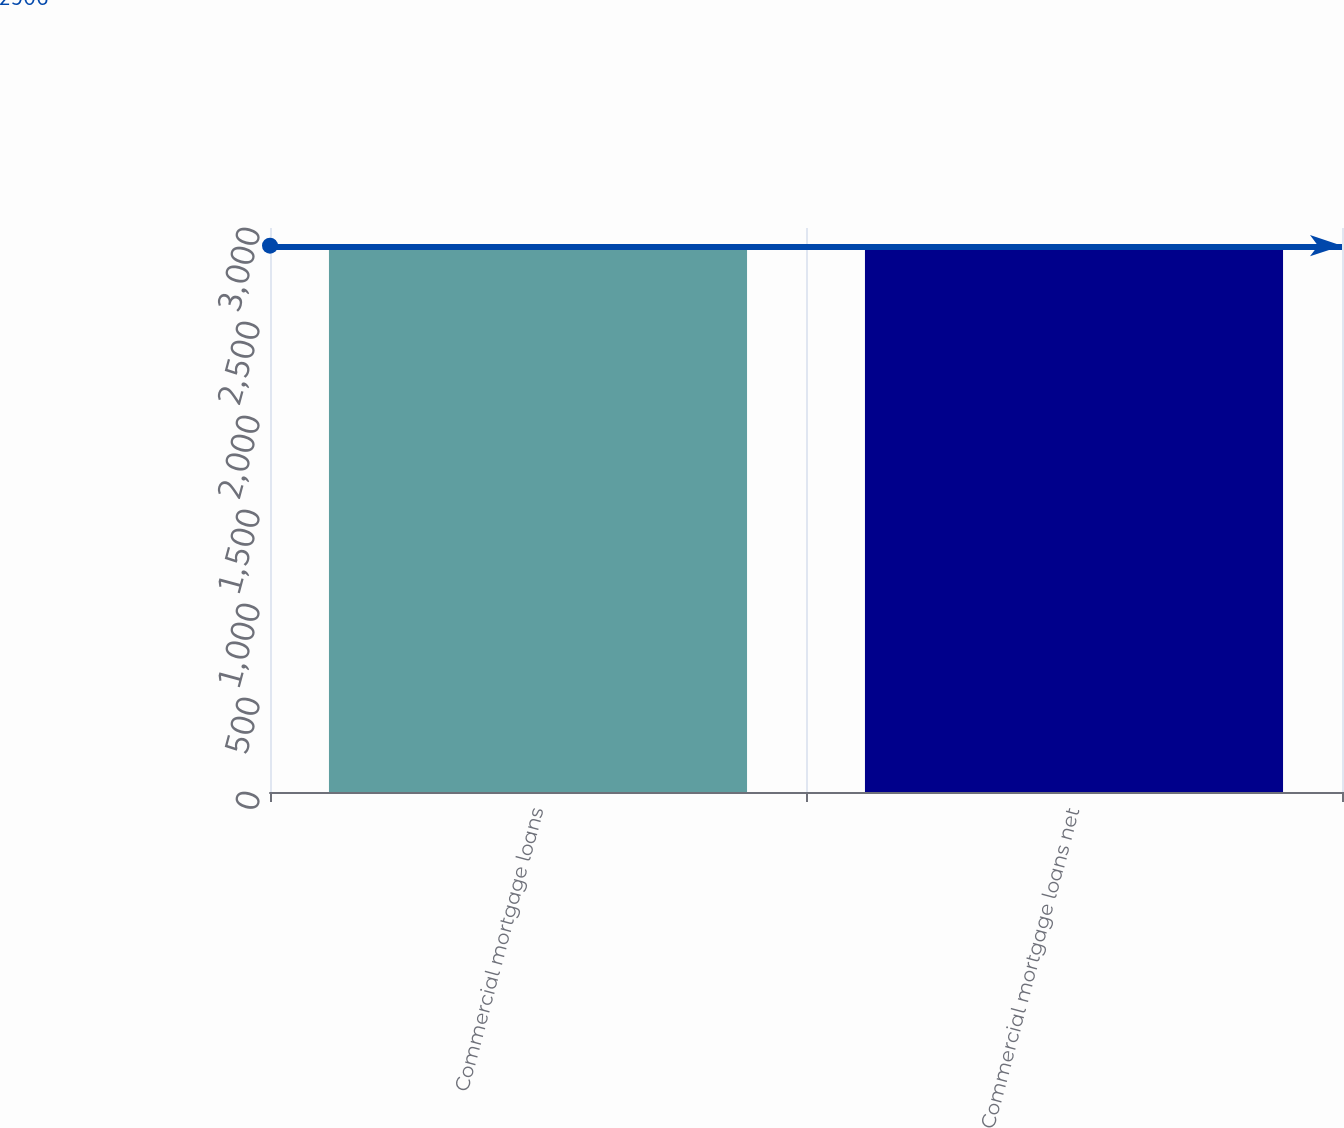<chart> <loc_0><loc_0><loc_500><loc_500><bar_chart><fcel>Commercial mortgage loans<fcel>Commercial mortgage loans net<nl><fcel>2906<fcel>2887<nl></chart> 